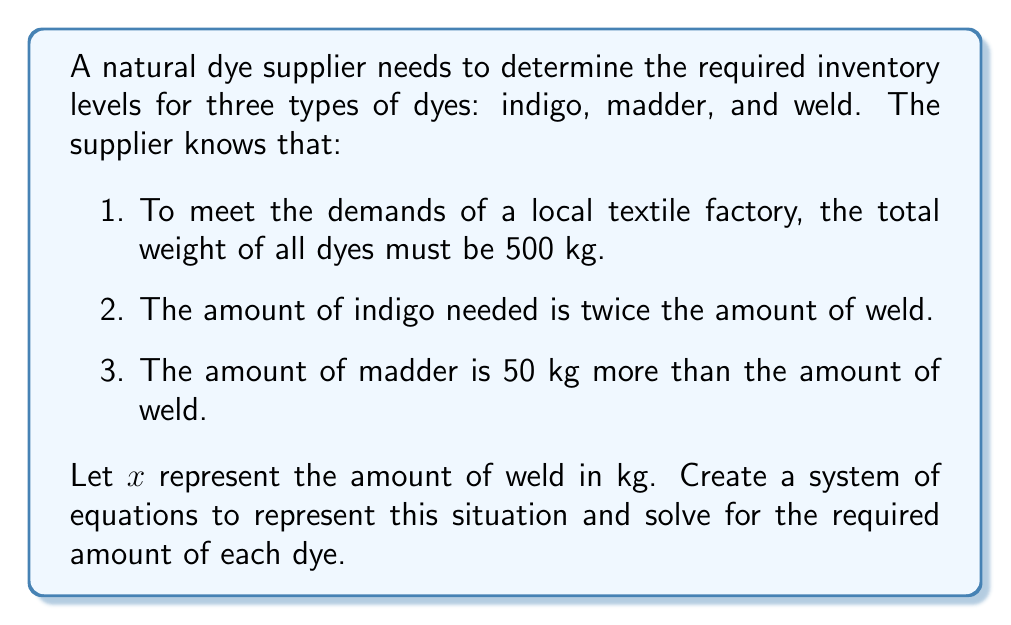What is the answer to this math problem? Let's approach this problem step by step:

1. Define variables:
   Let $x$ = amount of weld in kg
   Let $y$ = amount of indigo in kg
   Let $z$ = amount of madder in kg

2. Create equations based on the given information:
   a. Total weight equation: $x + y + z = 500$
   b. Indigo is twice the amount of weld: $y = 2x$
   c. Madder is 50 kg more than weld: $z = x + 50$

3. Substitute equations b and c into equation a:
   $x + 2x + (x + 50) = 500$

4. Simplify the equation:
   $4x + 50 = 500$

5. Solve for $x$:
   $4x = 450$
   $x = 112.5$

6. Calculate the amounts of indigo and madder:
   Indigo: $y = 2x = 2(112.5) = 225$
   Madder: $z = x + 50 = 112.5 + 50 = 162.5$

7. Verify the solution:
   Total weight: $112.5 + 225 + 162.5 = 500$ kg (correct)
   Indigo is twice weld: $225 = 2(112.5)$ (correct)
   Madder is 50 kg more than weld: $162.5 = 112.5 + 50$ (correct)

Therefore, the required inventory levels are:
Weld: 112.5 kg
Indigo: 225 kg
Madder: 162.5 kg
Answer: The required inventory levels are:
Weld: 112.5 kg
Indigo: 225 kg
Madder: 162.5 kg 